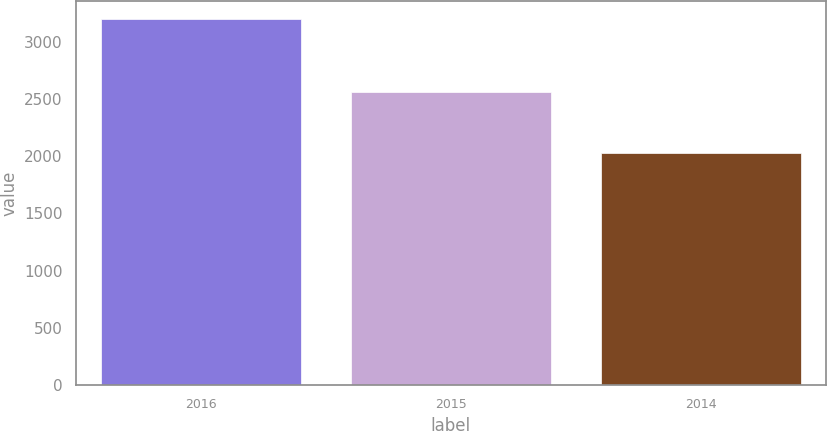Convert chart. <chart><loc_0><loc_0><loc_500><loc_500><bar_chart><fcel>2016<fcel>2015<fcel>2014<nl><fcel>3201<fcel>2561<fcel>2026<nl></chart> 